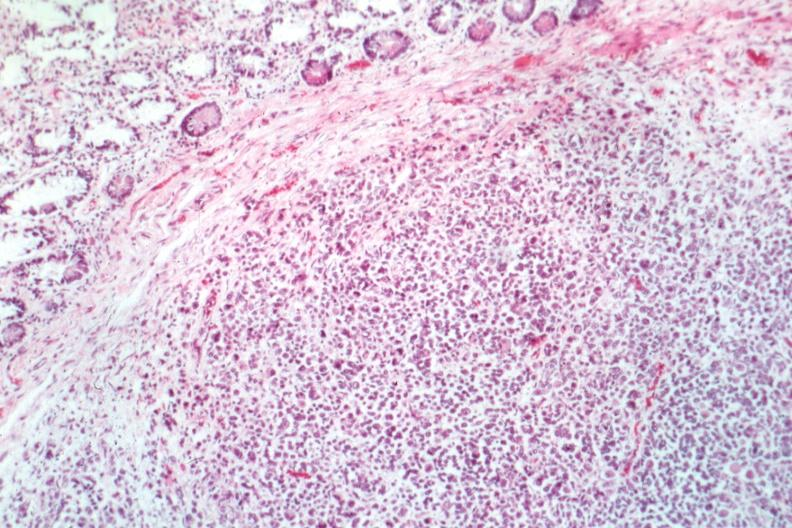where is this from?
Answer the question using a single word or phrase. Gastrointestinal system 